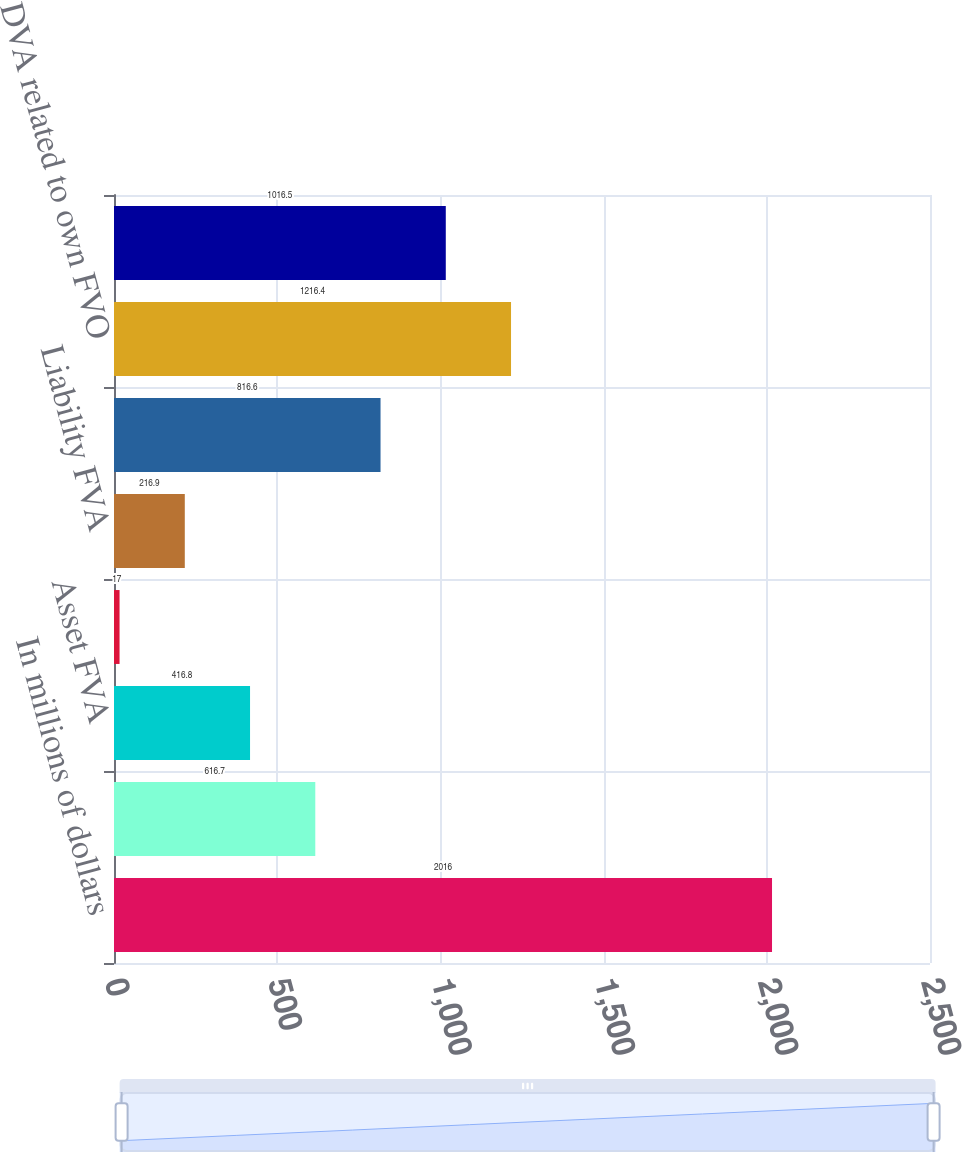Convert chart to OTSL. <chart><loc_0><loc_0><loc_500><loc_500><bar_chart><fcel>In millions of dollars<fcel>Counterparty CVA<fcel>Asset FVA<fcel>Own-credit CVA<fcel>Liability FVA<fcel>Total CVA-derivative<fcel>DVA related to own FVO<fcel>Total CVA and DVA (2)<nl><fcel>2016<fcel>616.7<fcel>416.8<fcel>17<fcel>216.9<fcel>816.6<fcel>1216.4<fcel>1016.5<nl></chart> 